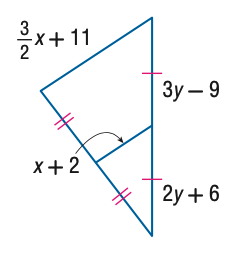Question: Find x.
Choices:
A. 8
B. 10
C. 12
D. 14
Answer with the letter. Answer: D Question: Find y.
Choices:
A. 13
B. 14
C. 15
D. 16
Answer with the letter. Answer: C 